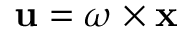Convert formula to latex. <formula><loc_0><loc_0><loc_500><loc_500>u = { \omega } \times x</formula> 